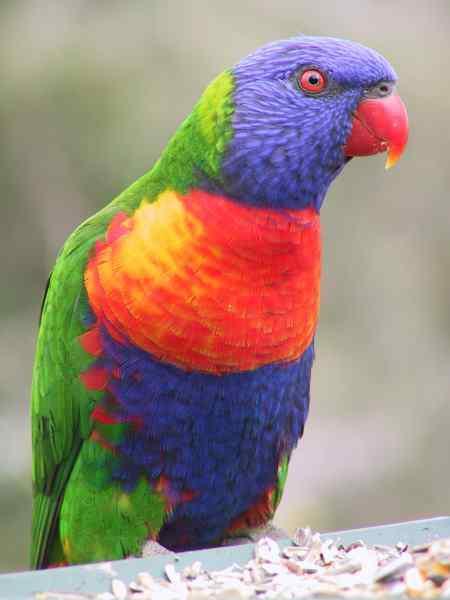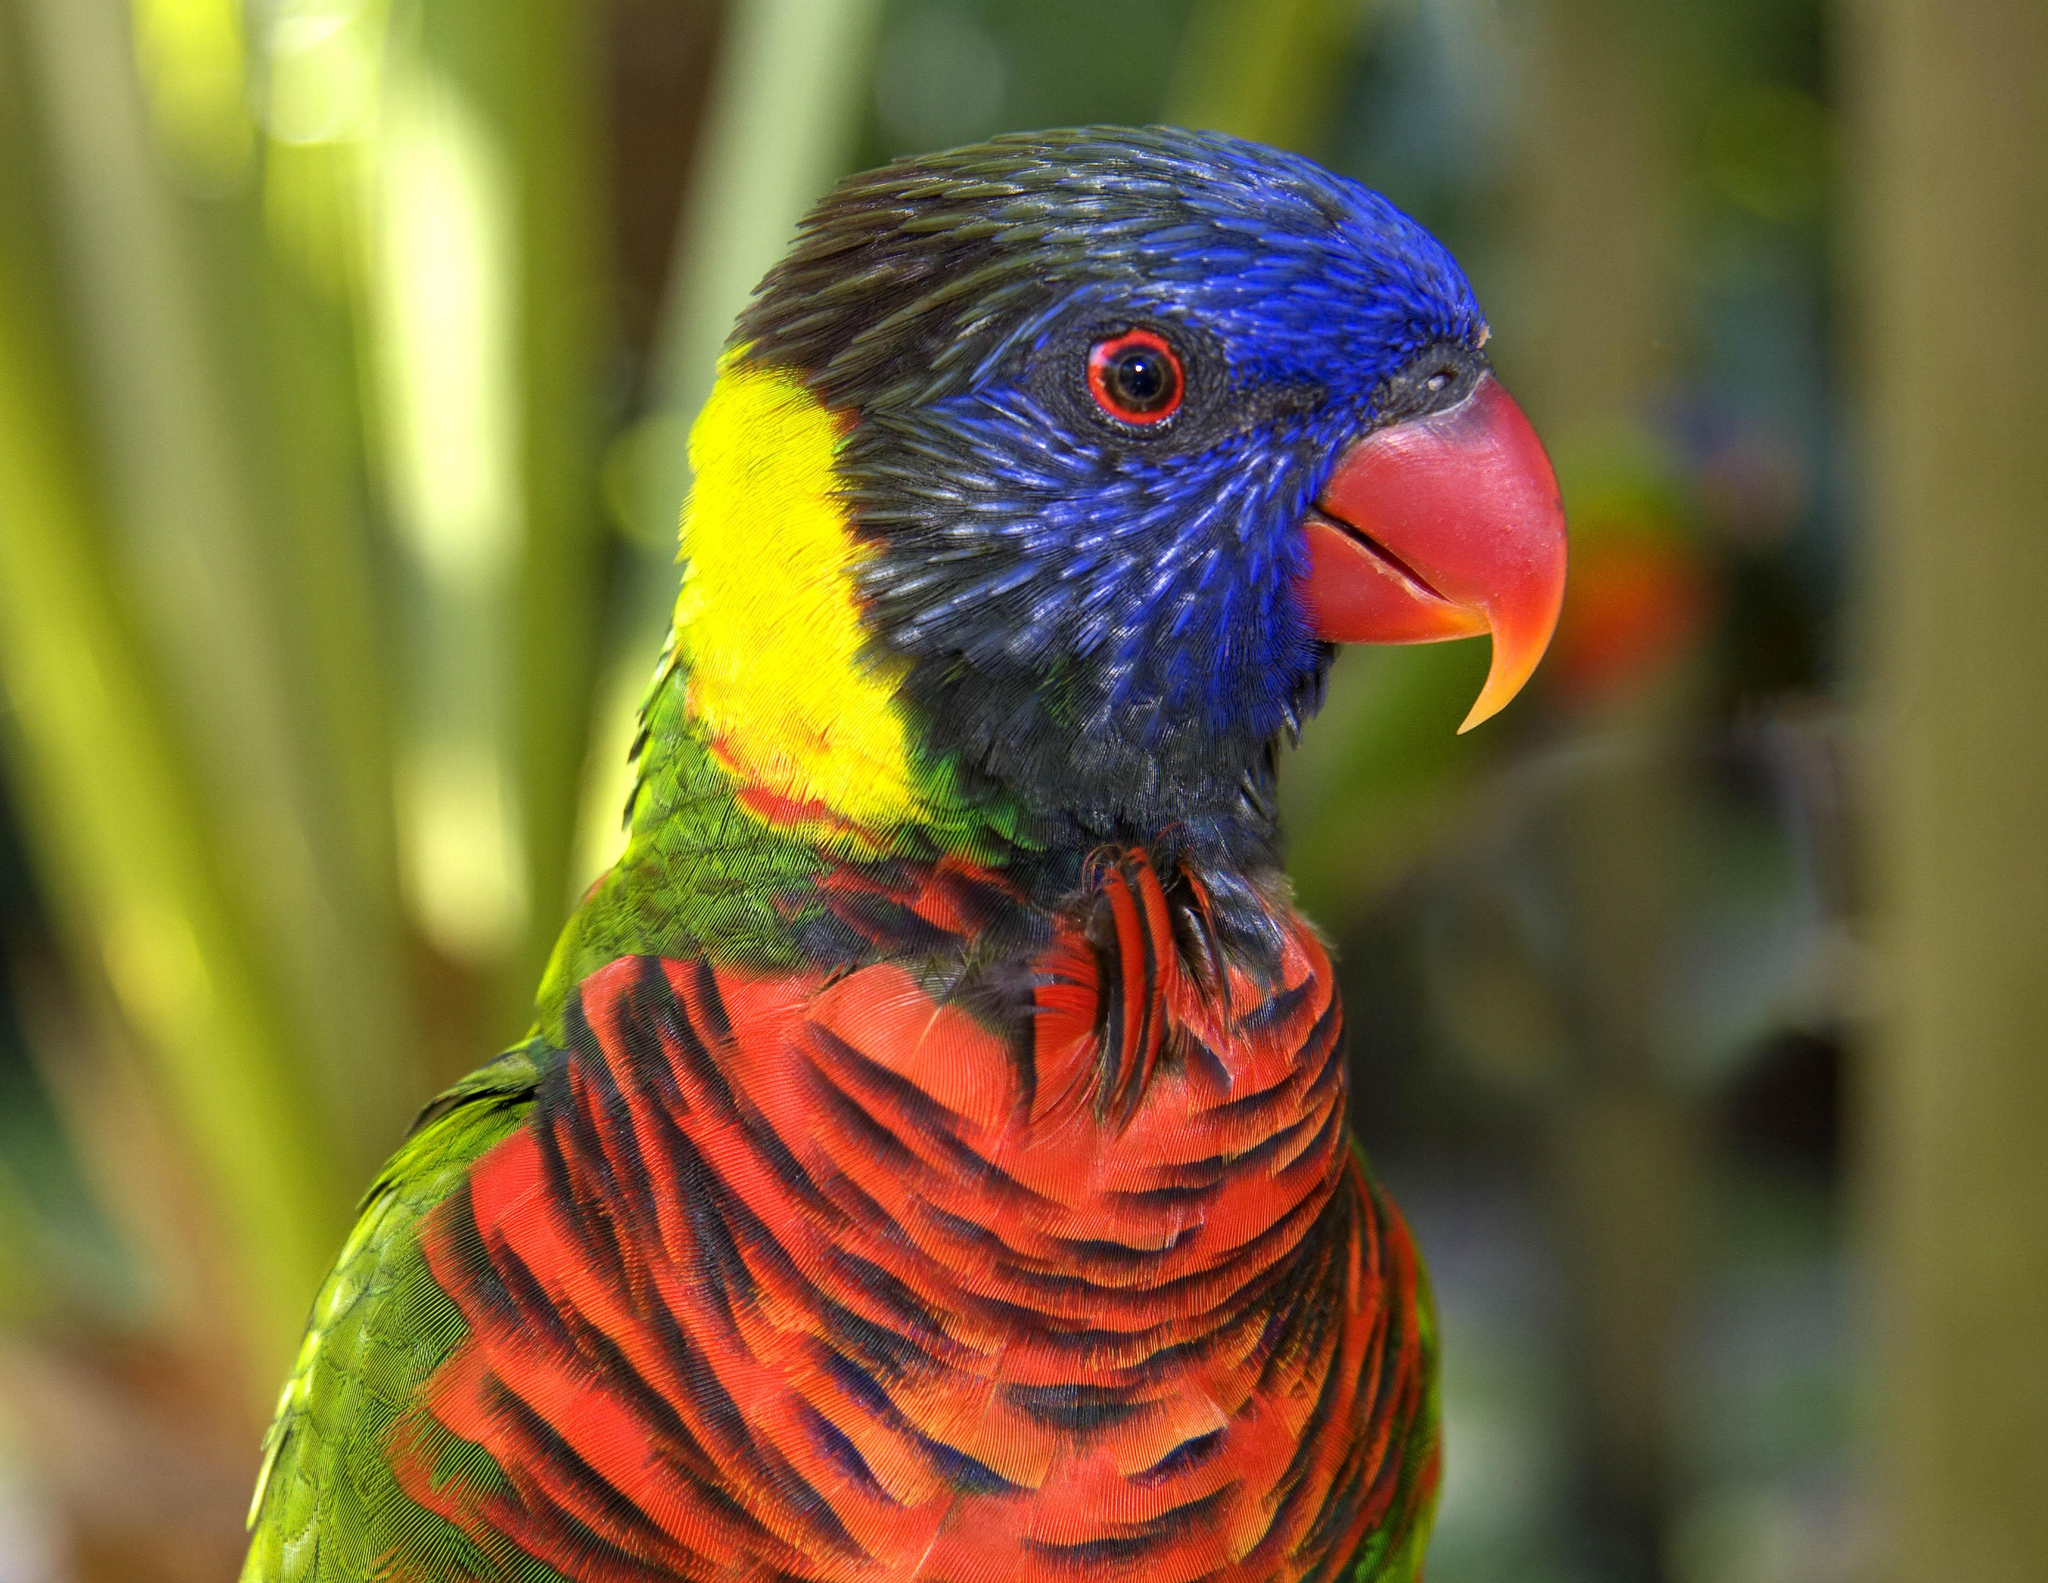The first image is the image on the left, the second image is the image on the right. Assess this claim about the two images: "There are two birds". Correct or not? Answer yes or no. Yes. The first image is the image on the left, the second image is the image on the right. Analyze the images presented: Is the assertion "There are two birds" valid? Answer yes or no. Yes. 